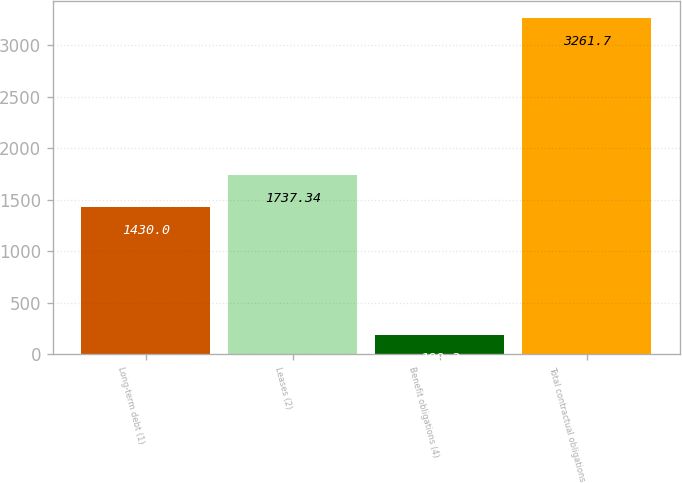Convert chart. <chart><loc_0><loc_0><loc_500><loc_500><bar_chart><fcel>Long-term debt (1)<fcel>Leases (2)<fcel>Benefit obligations (4)<fcel>Total contractual obligations<nl><fcel>1430<fcel>1737.34<fcel>188.3<fcel>3261.7<nl></chart> 